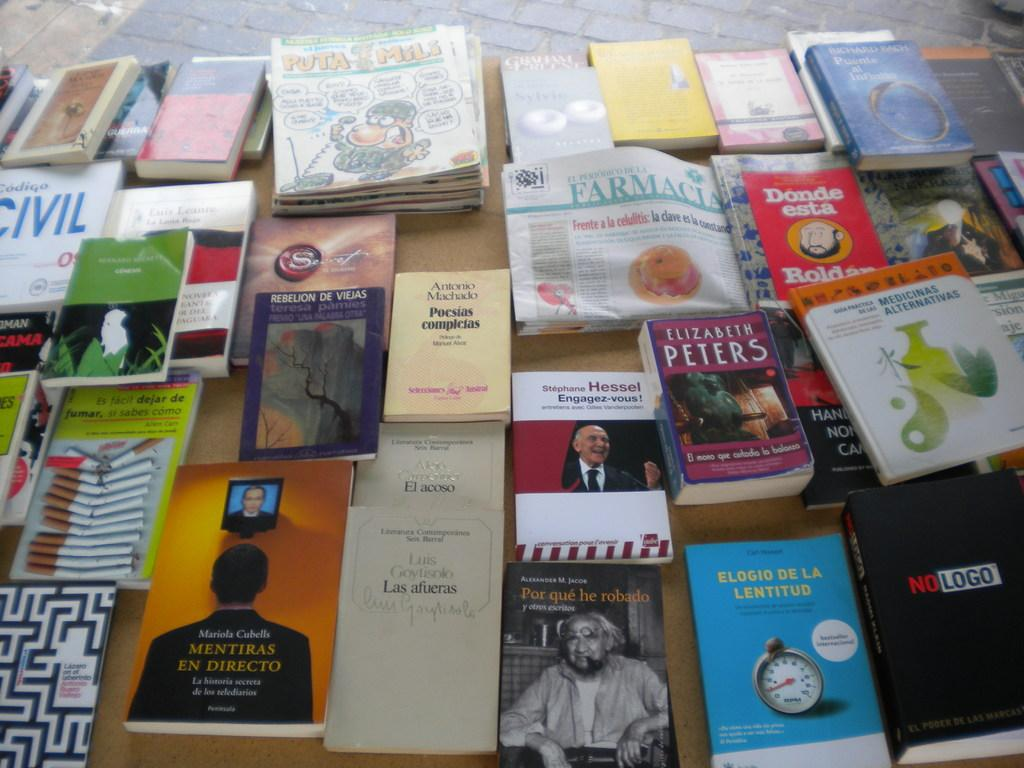Provide a one-sentence caption for the provided image. A lot of books from various artists including Elizabeth Peters. 